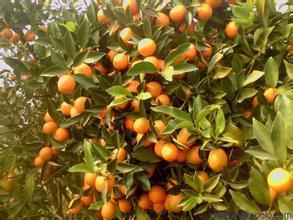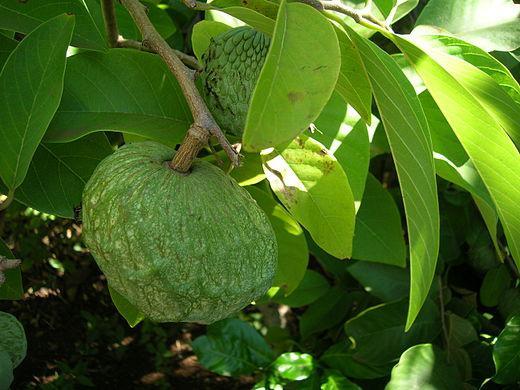The first image is the image on the left, the second image is the image on the right. For the images shown, is this caption "Yellow citrus fruit grow in the tree in the image on the left." true? Answer yes or no. Yes. 